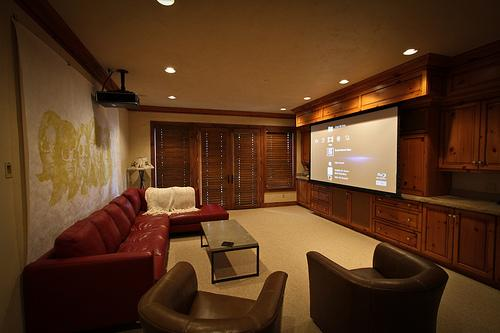List five noticeable elements in the image that may catch viewers' attention. Red leather sectional couch, projector screen, large white tapestry with yellow animals, windows with wooden blinds, and wall mural with five faces. Describe the setting where the image takes place using the most remarkable elements in it. The setting is a stylish living room with a red sectional sofa, brown leather chairs, glass coffee table, projector screen, and wooden cabinets near windows. Highlight the features that create a comfortable atmosphere in the room. A long couch, leather chairs, carpeted floor, ceiling light, and a floor lamp make the room comfortable and inviting. Describe the objects in the image related to lighting. There is a light on the ceiling, floor lamp behind the couch, tall black lamp with a white lamp shade, and a light switch on the wall. Mention three objects in the image that have a distinctive color and describe them. Red leather sectional couch with a white throw blanket, large white tapestry with yellow animals on the wall, and grey and black coffee table. Mention the main elements in the image that portray the room as a living room. A red leather couch with a white blanket, two brown chairs, coffee table, TV screen, and a projector in the ceiling make it a living room. Mention the different colors and materials of the furniture and decorations in the image. Red leather couch, brown leather chairs, grey and black coffee table, gold and white art on the wall, and white lamp shade with designs. Describe the image focusing on the electronic equipment present. There's a projector mounted on the ceiling, large TV screen, and a black remote control for the projector in a living room with other furniture. Provide a brief description of the main furniture in the image. There is a long red leather sofa, two brown leather chairs, a grey and black coffee table, and a brown wooden cabinet in the room. Describe the image focusing on the window and door areas. There are double wooden patio doors, cabinets near windows, windows with wooden blinds that are closed, and a lamp in the corner near the window. 